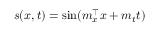<formula> <loc_0><loc_0><loc_500><loc_500>s ( x , t ) = \sin ( m _ { x } ^ { \top } x + m _ { t } t )</formula> 